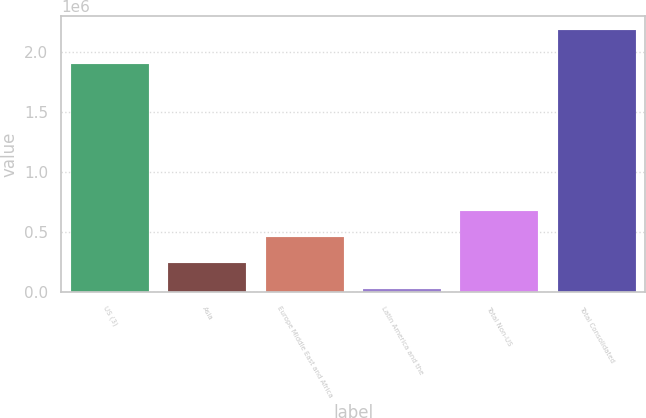Convert chart. <chart><loc_0><loc_0><loc_500><loc_500><bar_chart><fcel>US (3)<fcel>Asia<fcel>Europe Middle East and Africa<fcel>Latin America and the<fcel>Total Non-US<fcel>Total Consolidated<nl><fcel>1.90068e+06<fcel>242782<fcel>458884<fcel>26680<fcel>674987<fcel>2.1877e+06<nl></chart> 